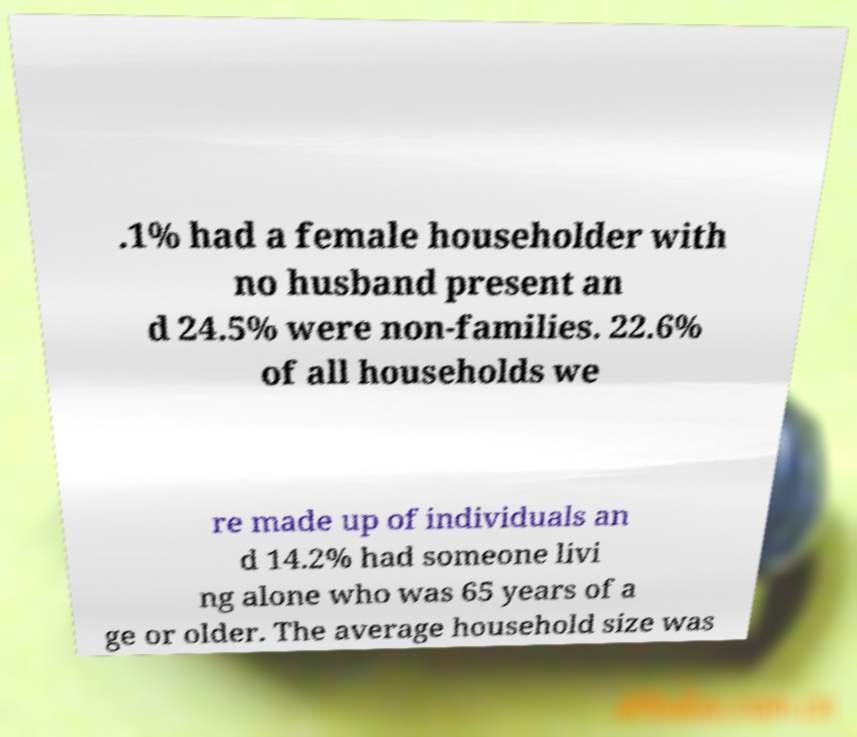Please identify and transcribe the text found in this image. .1% had a female householder with no husband present an d 24.5% were non-families. 22.6% of all households we re made up of individuals an d 14.2% had someone livi ng alone who was 65 years of a ge or older. The average household size was 